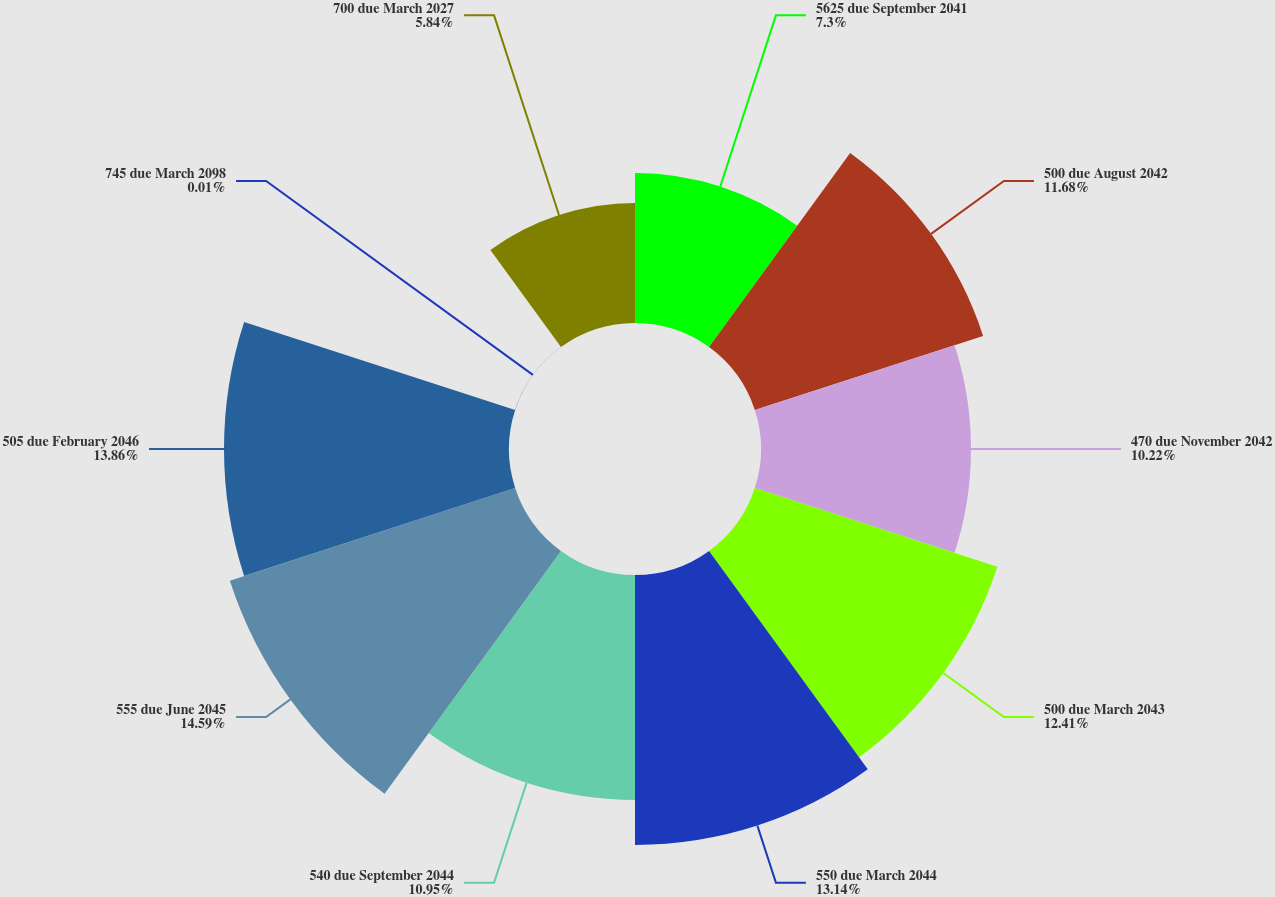Convert chart to OTSL. <chart><loc_0><loc_0><loc_500><loc_500><pie_chart><fcel>5625 due September 2041<fcel>500 due August 2042<fcel>470 due November 2042<fcel>500 due March 2043<fcel>550 due March 2044<fcel>540 due September 2044<fcel>555 due June 2045<fcel>505 due February 2046<fcel>745 due March 2098<fcel>700 due March 2027<nl><fcel>7.3%<fcel>11.68%<fcel>10.22%<fcel>12.41%<fcel>13.14%<fcel>10.95%<fcel>14.6%<fcel>13.87%<fcel>0.01%<fcel>5.84%<nl></chart> 